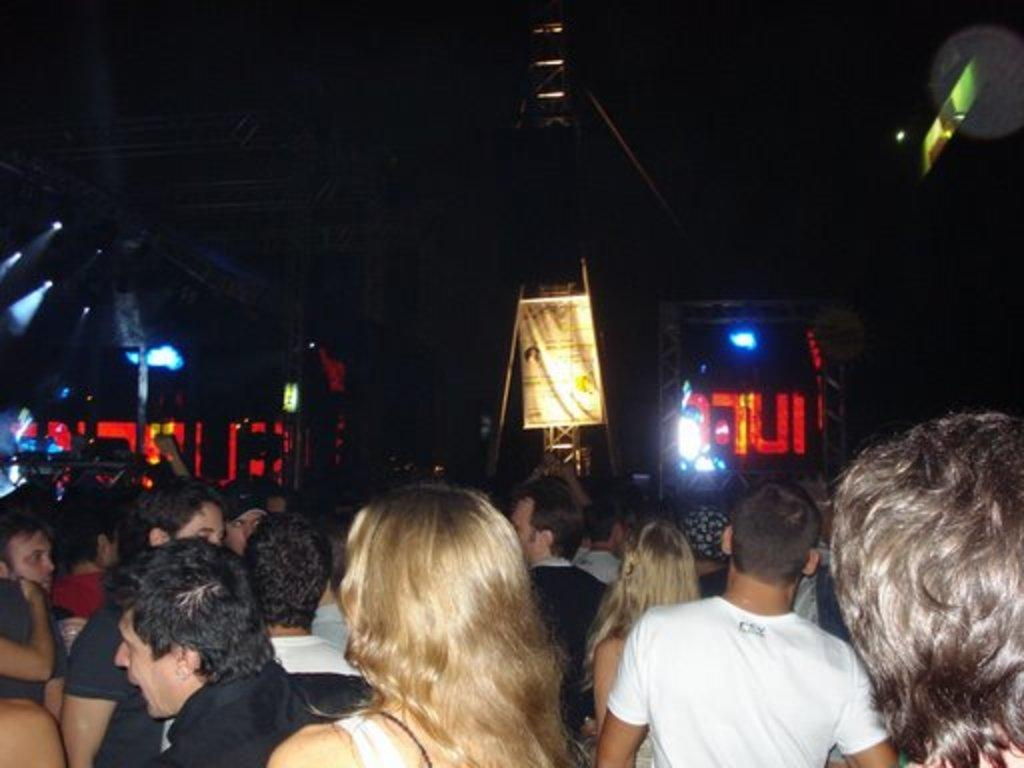What is happening in the image? There are people standing in the image. What can be seen in the background of the image? There is a banner, poles, lights, a screen, and other unspecified items in the background of the image. Can you describe the banner in the background? Unfortunately, the facts provided do not give enough detail to describe the banner. What might the purpose of the screen be in the background? The screen in the background might be used for displaying information or visuals during an event or gathering. How many zippers are visible on the people in the image? There is no mention of zippers in the image, so it is not possible to answer this question. What is the size of the ear of the person standing closest to the screen? There is no information about the size of anyone's ear in the image, so it is not possible to answer this question. 